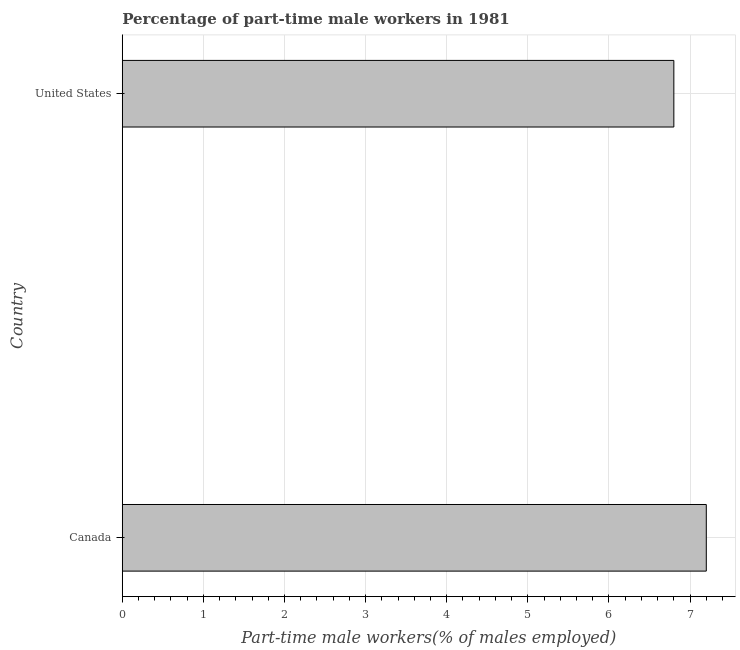Does the graph contain any zero values?
Give a very brief answer. No. What is the title of the graph?
Make the answer very short. Percentage of part-time male workers in 1981. What is the label or title of the X-axis?
Your response must be concise. Part-time male workers(% of males employed). What is the percentage of part-time male workers in United States?
Provide a short and direct response. 6.8. Across all countries, what is the maximum percentage of part-time male workers?
Offer a very short reply. 7.2. Across all countries, what is the minimum percentage of part-time male workers?
Give a very brief answer. 6.8. In which country was the percentage of part-time male workers minimum?
Offer a terse response. United States. What is the sum of the percentage of part-time male workers?
Keep it short and to the point. 14. What is the difference between the percentage of part-time male workers in Canada and United States?
Offer a very short reply. 0.4. What is the average percentage of part-time male workers per country?
Your answer should be very brief. 7. What is the median percentage of part-time male workers?
Offer a terse response. 7. In how many countries, is the percentage of part-time male workers greater than 1.4 %?
Keep it short and to the point. 2. What is the ratio of the percentage of part-time male workers in Canada to that in United States?
Provide a succinct answer. 1.06. In how many countries, is the percentage of part-time male workers greater than the average percentage of part-time male workers taken over all countries?
Provide a succinct answer. 1. Are all the bars in the graph horizontal?
Provide a short and direct response. Yes. How many countries are there in the graph?
Make the answer very short. 2. Are the values on the major ticks of X-axis written in scientific E-notation?
Ensure brevity in your answer.  No. What is the Part-time male workers(% of males employed) in Canada?
Make the answer very short. 7.2. What is the Part-time male workers(% of males employed) in United States?
Give a very brief answer. 6.8. What is the ratio of the Part-time male workers(% of males employed) in Canada to that in United States?
Provide a short and direct response. 1.06. 